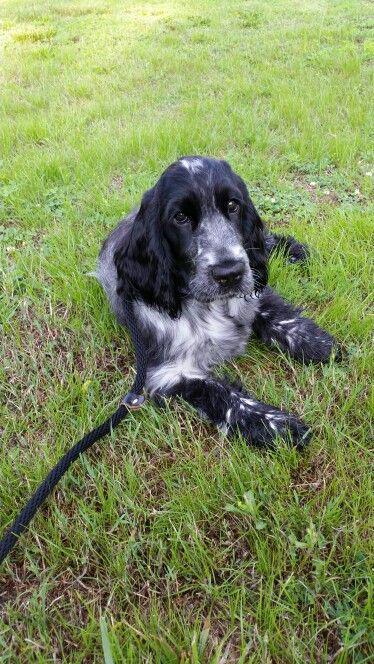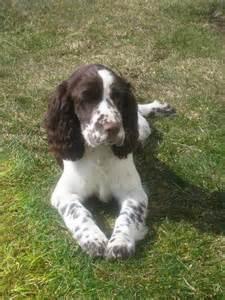The first image is the image on the left, the second image is the image on the right. Given the left and right images, does the statement "One dog is sitting with its tongue hanging out." hold true? Answer yes or no. No. The first image is the image on the left, the second image is the image on the right. Evaluate the accuracy of this statement regarding the images: "The dog on the left has its tongue out.". Is it true? Answer yes or no. No. 